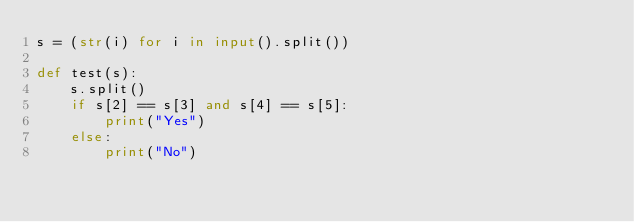Convert code to text. <code><loc_0><loc_0><loc_500><loc_500><_Python_>s = (str(i) for i in input().split())

def test(s):
    s.split()
    if s[2] == s[3] and s[4] == s[5]:
        print("Yes")
    else:
        print("No")</code> 